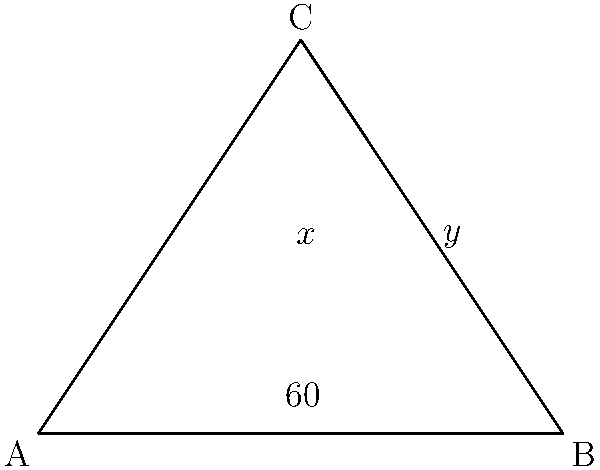In the traditional Punjabi turban wrapping technique, the folds often form triangular patterns. In the diagram above, representing a section of a turban fold, angle BAC measures 60°. If angle ACB is twice angle ABC, find the measure of angle BCA (represented by $x°$ in the diagram). Let's solve this step-by-step:

1) In any triangle, the sum of all angles is 180°.

2) Let's denote angle ABC as $y°$. We're told that angle ACB is twice angle ABC, so angle ACB = $2y°$.

3) We can now write an equation:
   $$60° + y° + 2y° = 180°$$

4) Simplify:
   $$60° + 3y° = 180°$$

5) Subtract 60° from both sides:
   $$3y° = 120°$$

6) Divide both sides by 3:
   $$y° = 40°$$

7) Now we know that angle ABC (y°) is 40°, and angle ACB is twice this, so it's 80°.

8) To find angle BCA (x°), we can subtract the other two angles from 180°:
   $$x° = 180° - 60° - 80° = 40°$$

Therefore, angle BCA (x°) measures 40°.
Answer: 40° 